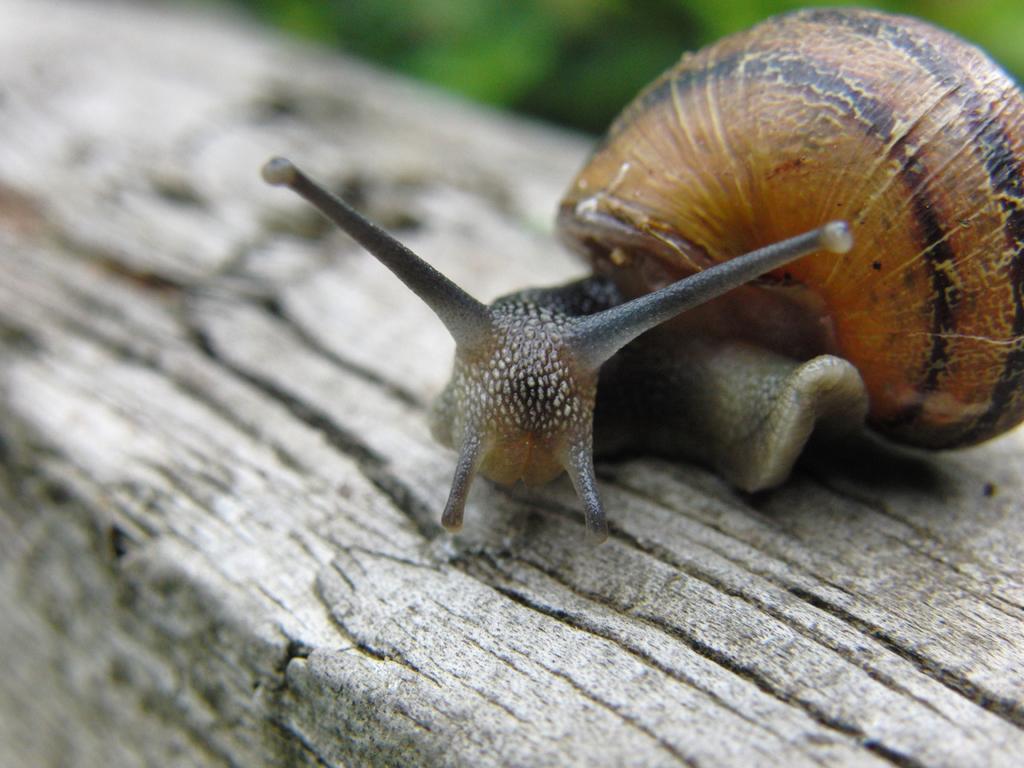How would you summarize this image in a sentence or two? In the center of the image there is a snail on the wood. 